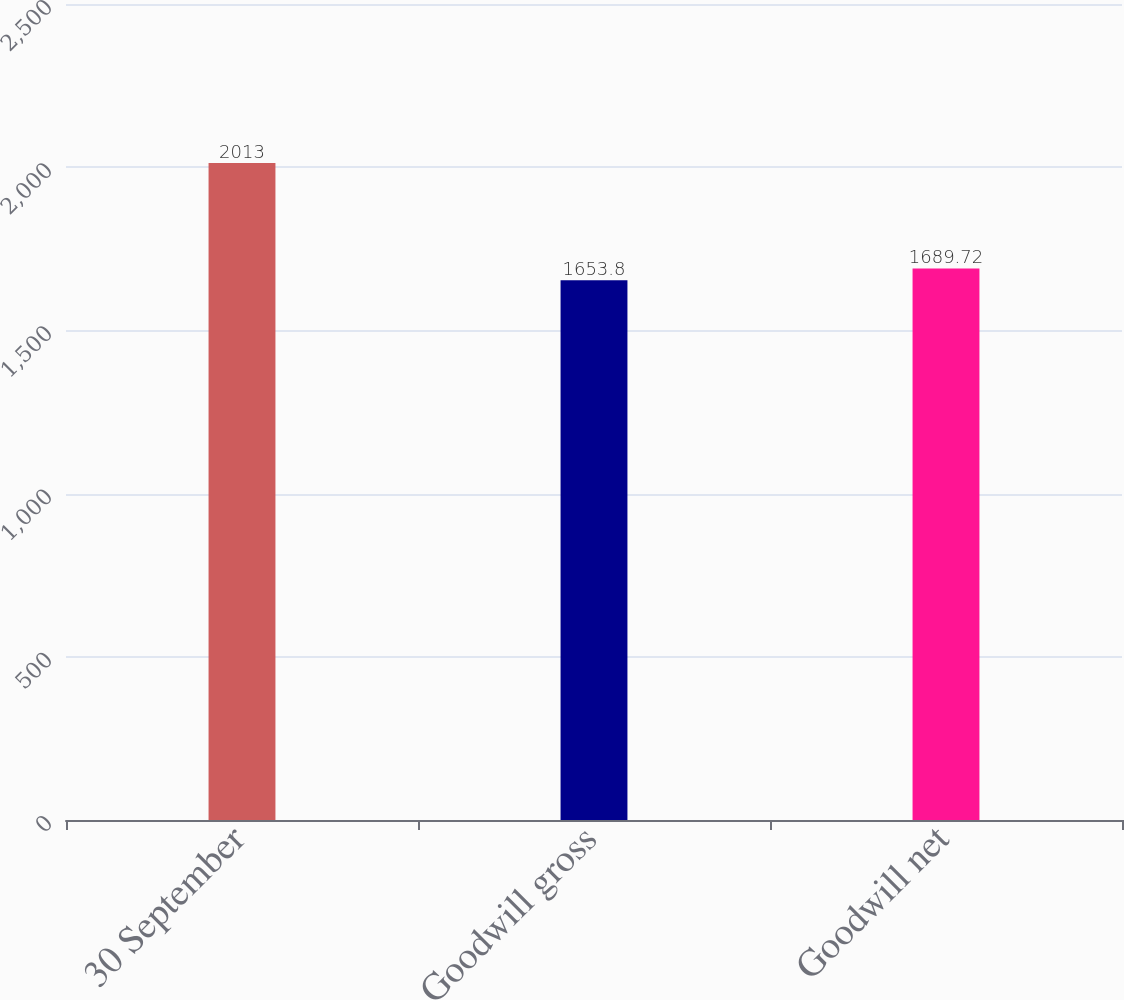Convert chart. <chart><loc_0><loc_0><loc_500><loc_500><bar_chart><fcel>30 September<fcel>Goodwill gross<fcel>Goodwill net<nl><fcel>2013<fcel>1653.8<fcel>1689.72<nl></chart> 